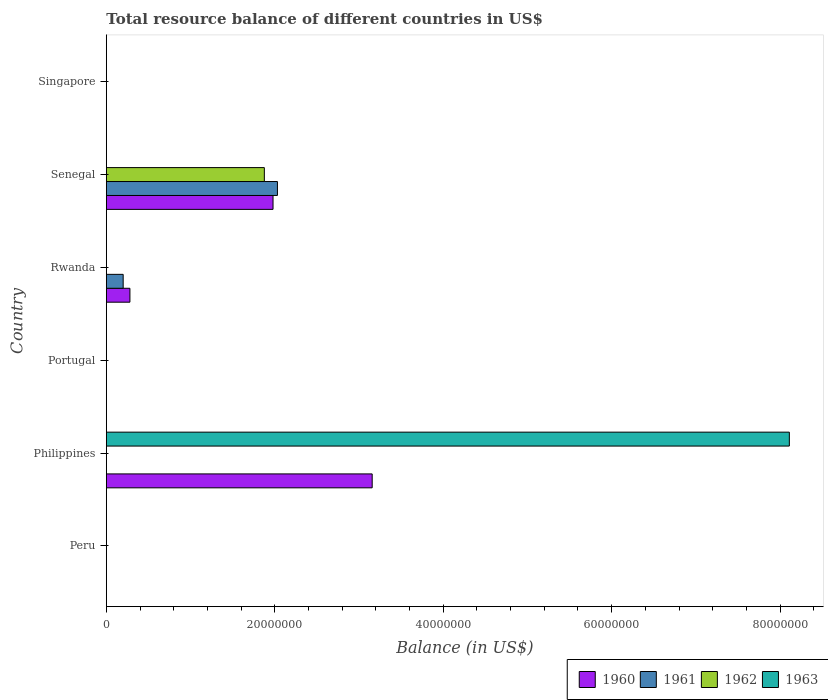How many different coloured bars are there?
Give a very brief answer. 4. Are the number of bars per tick equal to the number of legend labels?
Your response must be concise. No. Are the number of bars on each tick of the Y-axis equal?
Offer a terse response. No. How many bars are there on the 3rd tick from the top?
Your answer should be compact. 2. How many bars are there on the 1st tick from the bottom?
Your answer should be very brief. 0. What is the label of the 2nd group of bars from the top?
Provide a succinct answer. Senegal. What is the total resource balance in 1961 in Rwanda?
Your answer should be very brief. 2.00e+06. Across all countries, what is the maximum total resource balance in 1961?
Give a very brief answer. 2.03e+07. What is the total total resource balance in 1960 in the graph?
Ensure brevity in your answer.  5.42e+07. What is the average total resource balance in 1961 per country?
Offer a very short reply. 3.72e+06. What is the difference between the total resource balance in 1960 and total resource balance in 1962 in Senegal?
Your answer should be very brief. 1.03e+06. In how many countries, is the total resource balance in 1963 greater than 36000000 US$?
Ensure brevity in your answer.  1. What is the difference between the highest and the second highest total resource balance in 1960?
Make the answer very short. 1.18e+07. What is the difference between the highest and the lowest total resource balance in 1962?
Give a very brief answer. 1.88e+07. Is the sum of the total resource balance in 1961 in Rwanda and Senegal greater than the maximum total resource balance in 1962 across all countries?
Make the answer very short. Yes. Is it the case that in every country, the sum of the total resource balance in 1961 and total resource balance in 1963 is greater than the sum of total resource balance in 1960 and total resource balance in 1962?
Your answer should be very brief. No. Is it the case that in every country, the sum of the total resource balance in 1961 and total resource balance in 1963 is greater than the total resource balance in 1960?
Keep it short and to the point. No. How many bars are there?
Your response must be concise. 7. What is the difference between two consecutive major ticks on the X-axis?
Provide a succinct answer. 2.00e+07. Does the graph contain any zero values?
Ensure brevity in your answer.  Yes. Where does the legend appear in the graph?
Your answer should be compact. Bottom right. What is the title of the graph?
Offer a very short reply. Total resource balance of different countries in US$. What is the label or title of the X-axis?
Keep it short and to the point. Balance (in US$). What is the Balance (in US$) of 1962 in Peru?
Provide a succinct answer. 0. What is the Balance (in US$) of 1963 in Peru?
Your answer should be compact. 0. What is the Balance (in US$) of 1960 in Philippines?
Ensure brevity in your answer.  3.16e+07. What is the Balance (in US$) in 1963 in Philippines?
Your response must be concise. 8.11e+07. What is the Balance (in US$) of 1960 in Portugal?
Your answer should be compact. 0. What is the Balance (in US$) of 1961 in Portugal?
Give a very brief answer. 0. What is the Balance (in US$) of 1963 in Portugal?
Offer a very short reply. 0. What is the Balance (in US$) of 1960 in Rwanda?
Provide a succinct answer. 2.80e+06. What is the Balance (in US$) of 1961 in Rwanda?
Your answer should be very brief. 2.00e+06. What is the Balance (in US$) in 1962 in Rwanda?
Keep it short and to the point. 0. What is the Balance (in US$) of 1960 in Senegal?
Your response must be concise. 1.98e+07. What is the Balance (in US$) in 1961 in Senegal?
Provide a short and direct response. 2.03e+07. What is the Balance (in US$) in 1962 in Senegal?
Keep it short and to the point. 1.88e+07. What is the Balance (in US$) of 1963 in Senegal?
Keep it short and to the point. 0. What is the Balance (in US$) of 1962 in Singapore?
Your answer should be compact. 0. What is the Balance (in US$) in 1963 in Singapore?
Provide a short and direct response. 0. Across all countries, what is the maximum Balance (in US$) of 1960?
Give a very brief answer. 3.16e+07. Across all countries, what is the maximum Balance (in US$) in 1961?
Offer a terse response. 2.03e+07. Across all countries, what is the maximum Balance (in US$) in 1962?
Offer a terse response. 1.88e+07. Across all countries, what is the maximum Balance (in US$) of 1963?
Offer a terse response. 8.11e+07. Across all countries, what is the minimum Balance (in US$) of 1960?
Your answer should be very brief. 0. Across all countries, what is the minimum Balance (in US$) of 1962?
Provide a succinct answer. 0. Across all countries, what is the minimum Balance (in US$) in 1963?
Your answer should be very brief. 0. What is the total Balance (in US$) of 1960 in the graph?
Your answer should be compact. 5.42e+07. What is the total Balance (in US$) in 1961 in the graph?
Offer a very short reply. 2.23e+07. What is the total Balance (in US$) in 1962 in the graph?
Provide a short and direct response. 1.88e+07. What is the total Balance (in US$) in 1963 in the graph?
Your answer should be compact. 8.11e+07. What is the difference between the Balance (in US$) in 1960 in Philippines and that in Rwanda?
Provide a succinct answer. 2.88e+07. What is the difference between the Balance (in US$) in 1960 in Philippines and that in Senegal?
Provide a short and direct response. 1.18e+07. What is the difference between the Balance (in US$) of 1960 in Rwanda and that in Senegal?
Make the answer very short. -1.70e+07. What is the difference between the Balance (in US$) of 1961 in Rwanda and that in Senegal?
Keep it short and to the point. -1.83e+07. What is the difference between the Balance (in US$) of 1960 in Philippines and the Balance (in US$) of 1961 in Rwanda?
Your response must be concise. 2.96e+07. What is the difference between the Balance (in US$) of 1960 in Philippines and the Balance (in US$) of 1961 in Senegal?
Provide a succinct answer. 1.12e+07. What is the difference between the Balance (in US$) of 1960 in Philippines and the Balance (in US$) of 1962 in Senegal?
Provide a succinct answer. 1.28e+07. What is the difference between the Balance (in US$) of 1960 in Rwanda and the Balance (in US$) of 1961 in Senegal?
Give a very brief answer. -1.75e+07. What is the difference between the Balance (in US$) in 1960 in Rwanda and the Balance (in US$) in 1962 in Senegal?
Give a very brief answer. -1.60e+07. What is the difference between the Balance (in US$) of 1961 in Rwanda and the Balance (in US$) of 1962 in Senegal?
Your answer should be very brief. -1.68e+07. What is the average Balance (in US$) in 1960 per country?
Make the answer very short. 9.03e+06. What is the average Balance (in US$) in 1961 per country?
Keep it short and to the point. 3.72e+06. What is the average Balance (in US$) of 1962 per country?
Provide a short and direct response. 3.13e+06. What is the average Balance (in US$) of 1963 per country?
Your response must be concise. 1.35e+07. What is the difference between the Balance (in US$) in 1960 and Balance (in US$) in 1963 in Philippines?
Your answer should be compact. -4.95e+07. What is the difference between the Balance (in US$) in 1960 and Balance (in US$) in 1961 in Rwanda?
Your response must be concise. 8.00e+05. What is the difference between the Balance (in US$) in 1960 and Balance (in US$) in 1961 in Senegal?
Ensure brevity in your answer.  -5.23e+05. What is the difference between the Balance (in US$) of 1960 and Balance (in US$) of 1962 in Senegal?
Your answer should be very brief. 1.03e+06. What is the difference between the Balance (in US$) in 1961 and Balance (in US$) in 1962 in Senegal?
Provide a short and direct response. 1.55e+06. What is the ratio of the Balance (in US$) of 1960 in Philippines to that in Rwanda?
Your response must be concise. 11.27. What is the ratio of the Balance (in US$) of 1960 in Philippines to that in Senegal?
Your response must be concise. 1.59. What is the ratio of the Balance (in US$) in 1960 in Rwanda to that in Senegal?
Provide a succinct answer. 0.14. What is the ratio of the Balance (in US$) of 1961 in Rwanda to that in Senegal?
Offer a very short reply. 0.1. What is the difference between the highest and the second highest Balance (in US$) in 1960?
Give a very brief answer. 1.18e+07. What is the difference between the highest and the lowest Balance (in US$) in 1960?
Ensure brevity in your answer.  3.16e+07. What is the difference between the highest and the lowest Balance (in US$) of 1961?
Give a very brief answer. 2.03e+07. What is the difference between the highest and the lowest Balance (in US$) of 1962?
Keep it short and to the point. 1.88e+07. What is the difference between the highest and the lowest Balance (in US$) of 1963?
Keep it short and to the point. 8.11e+07. 